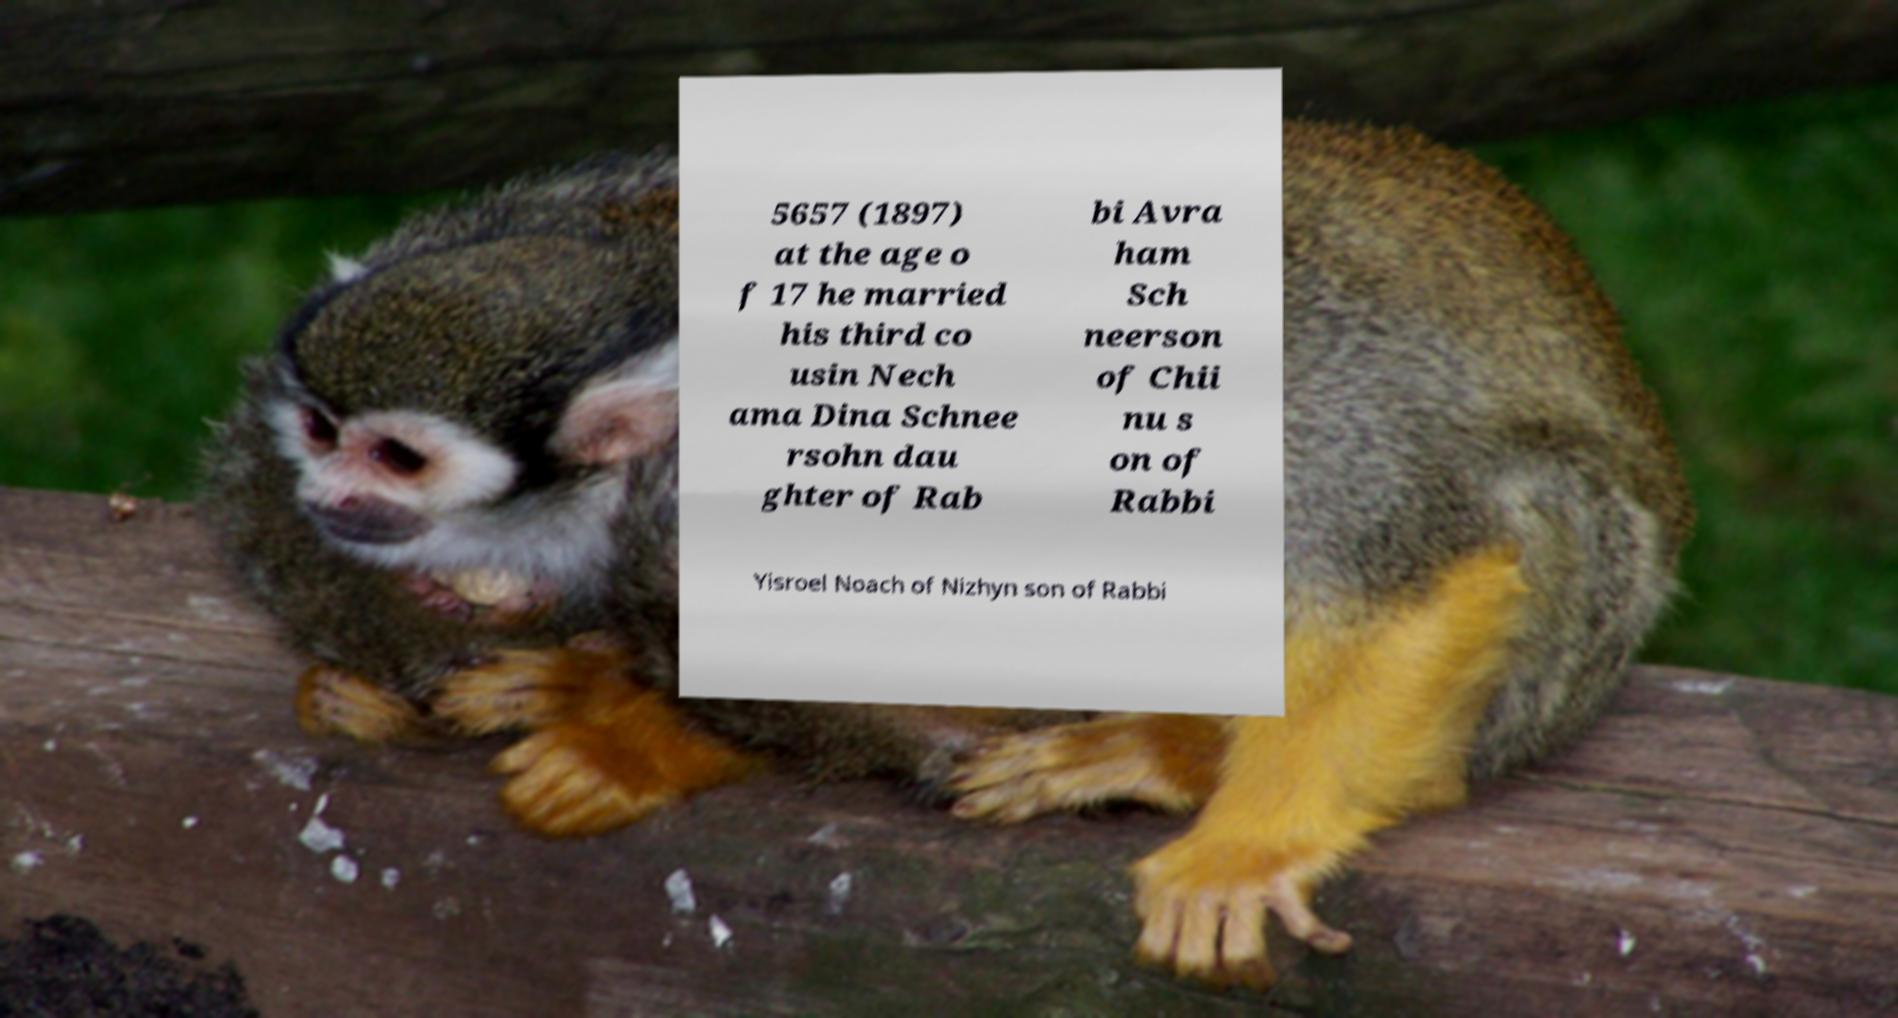Could you extract and type out the text from this image? 5657 (1897) at the age o f 17 he married his third co usin Nech ama Dina Schnee rsohn dau ghter of Rab bi Avra ham Sch neerson of Chii nu s on of Rabbi Yisroel Noach of Nizhyn son of Rabbi 